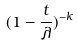Convert formula to latex. <formula><loc_0><loc_0><loc_500><loc_500>( 1 - \frac { t } { \lambda } ) ^ { - k }</formula> 